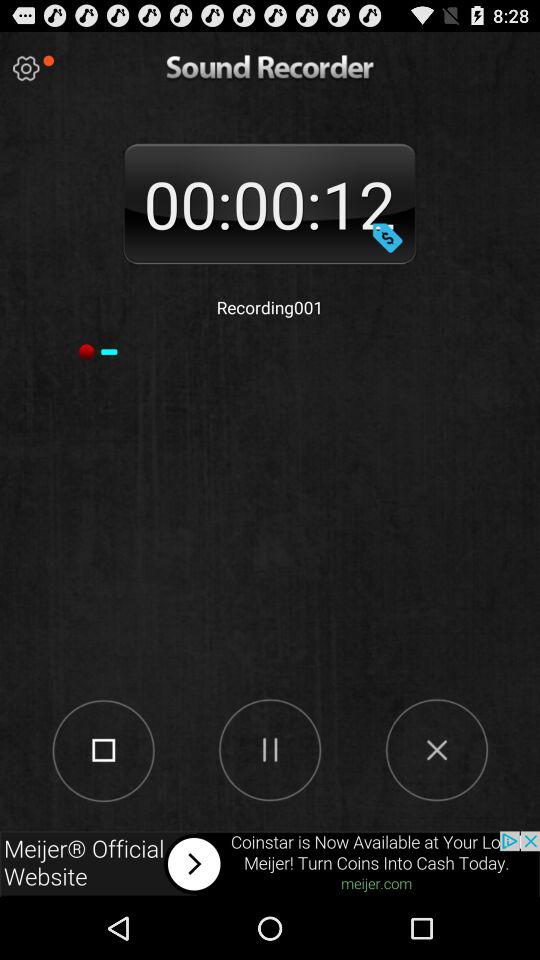How long has the recording been going on for?
Answer the question using a single word or phrase. 00:00:12 